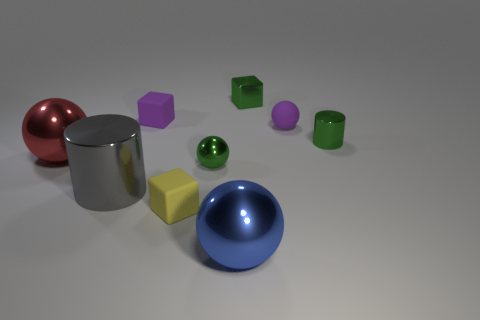Subtract all purple spheres. How many spheres are left? 3 Subtract all small rubber blocks. How many blocks are left? 1 Subtract 1 balls. How many balls are left? 3 Subtract all cyan balls. Subtract all yellow cylinders. How many balls are left? 4 Add 1 yellow cubes. How many objects exist? 10 Subtract all cylinders. How many objects are left? 7 Add 8 tiny red metallic things. How many tiny red metallic things exist? 8 Subtract 0 brown cubes. How many objects are left? 9 Subtract all small rubber balls. Subtract all small blocks. How many objects are left? 5 Add 1 small yellow rubber cubes. How many small yellow rubber cubes are left? 2 